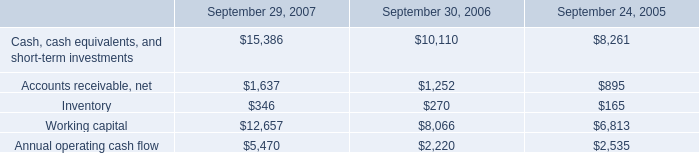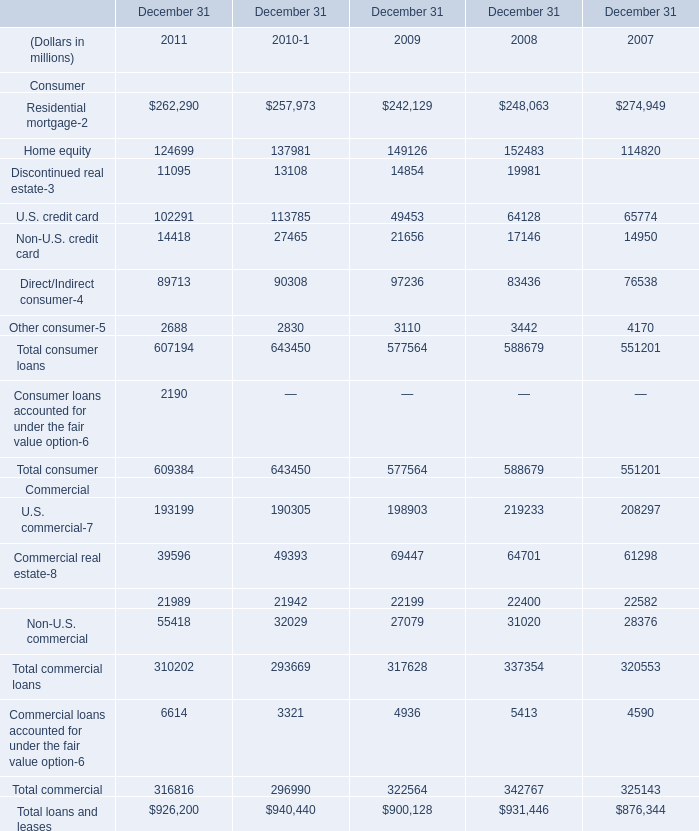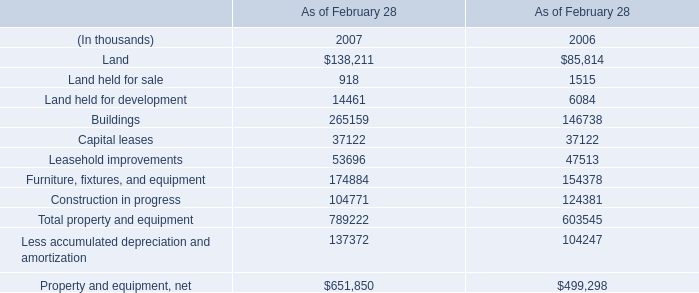What's the average of Direct/Indirect consumer of December 31 2008, and Land held for sale of As of February 28 2006 ? 
Computations: ((83436.0 + 1515.0) / 2)
Answer: 42475.5. 